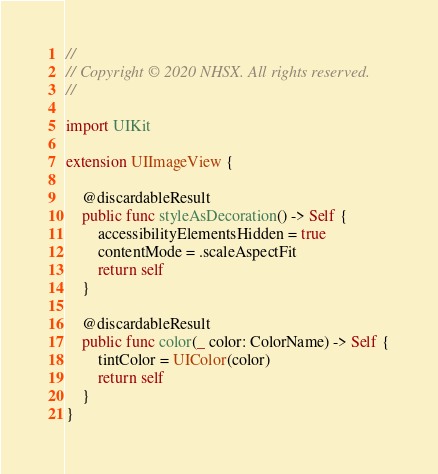Convert code to text. <code><loc_0><loc_0><loc_500><loc_500><_Swift_>//
// Copyright © 2020 NHSX. All rights reserved.
//

import UIKit

extension UIImageView {
    
    @discardableResult
    public func styleAsDecoration() -> Self {
        accessibilityElementsHidden = true
        contentMode = .scaleAspectFit
        return self
    }
    
    @discardableResult
    public func color(_ color: ColorName) -> Self {
        tintColor = UIColor(color)
        return self
    }
}
</code> 